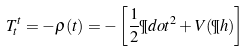<formula> <loc_0><loc_0><loc_500><loc_500>T ^ { t } _ { t } = - \rho ( t ) = - \left [ \frac { 1 } { 2 } \P d o t ^ { 2 } + V ( \P h ) \right ]</formula> 